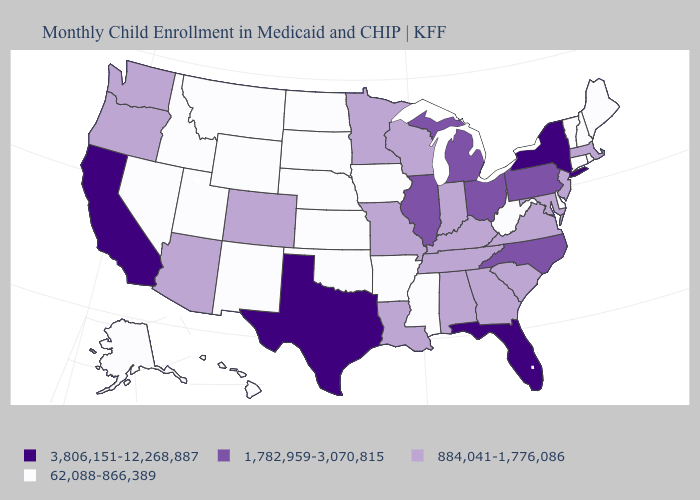What is the value of California?
Be succinct. 3,806,151-12,268,887. Name the states that have a value in the range 1,782,959-3,070,815?
Write a very short answer. Illinois, Michigan, North Carolina, Ohio, Pennsylvania. Does the first symbol in the legend represent the smallest category?
Give a very brief answer. No. What is the lowest value in the West?
Short answer required. 62,088-866,389. How many symbols are there in the legend?
Be succinct. 4. Name the states that have a value in the range 3,806,151-12,268,887?
Short answer required. California, Florida, New York, Texas. What is the value of Indiana?
Give a very brief answer. 884,041-1,776,086. Name the states that have a value in the range 884,041-1,776,086?
Answer briefly. Alabama, Arizona, Colorado, Georgia, Indiana, Kentucky, Louisiana, Maryland, Massachusetts, Minnesota, Missouri, New Jersey, Oregon, South Carolina, Tennessee, Virginia, Washington, Wisconsin. Does the map have missing data?
Keep it brief. No. What is the value of Georgia?
Answer briefly. 884,041-1,776,086. What is the highest value in the South ?
Write a very short answer. 3,806,151-12,268,887. What is the value of Illinois?
Keep it brief. 1,782,959-3,070,815. What is the value of Maine?
Quick response, please. 62,088-866,389. What is the value of Minnesota?
Write a very short answer. 884,041-1,776,086. What is the highest value in states that border California?
Quick response, please. 884,041-1,776,086. 